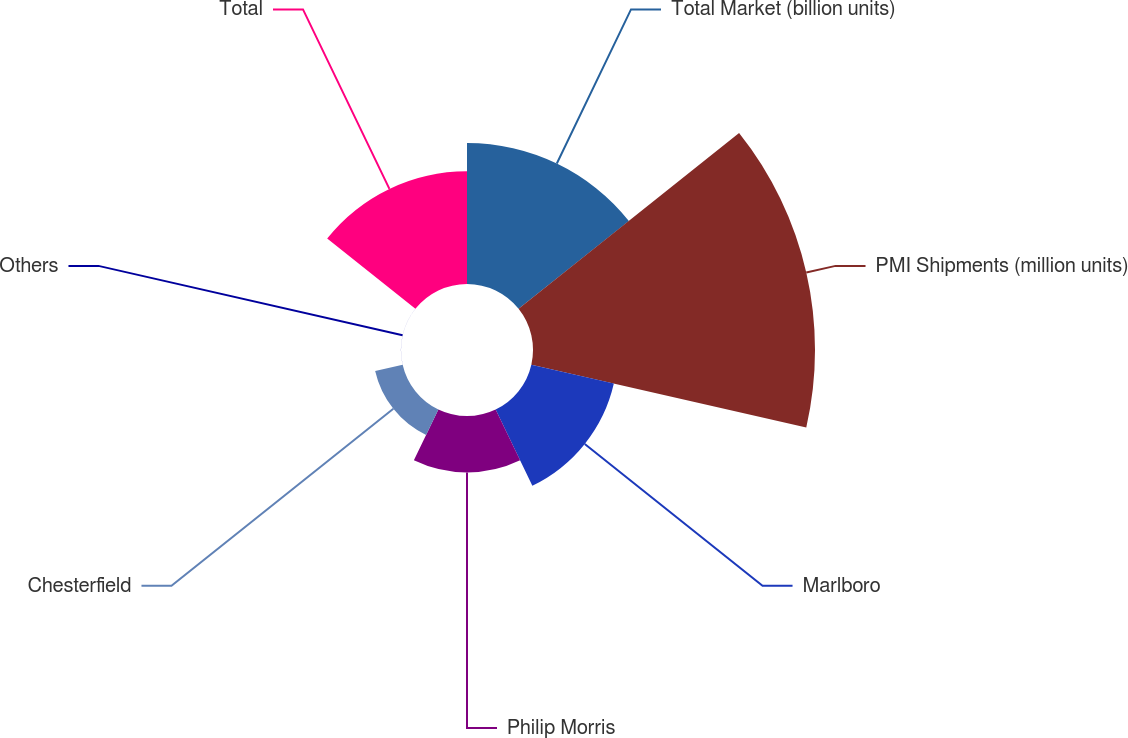<chart> <loc_0><loc_0><loc_500><loc_500><pie_chart><fcel>Total Market (billion units)<fcel>PMI Shipments (million units)<fcel>Marlboro<fcel>Philip Morris<fcel>Chesterfield<fcel>Others<fcel>Total<nl><fcel>20.0%<fcel>39.99%<fcel>12.0%<fcel>8.0%<fcel>4.0%<fcel>0.01%<fcel>16.0%<nl></chart> 